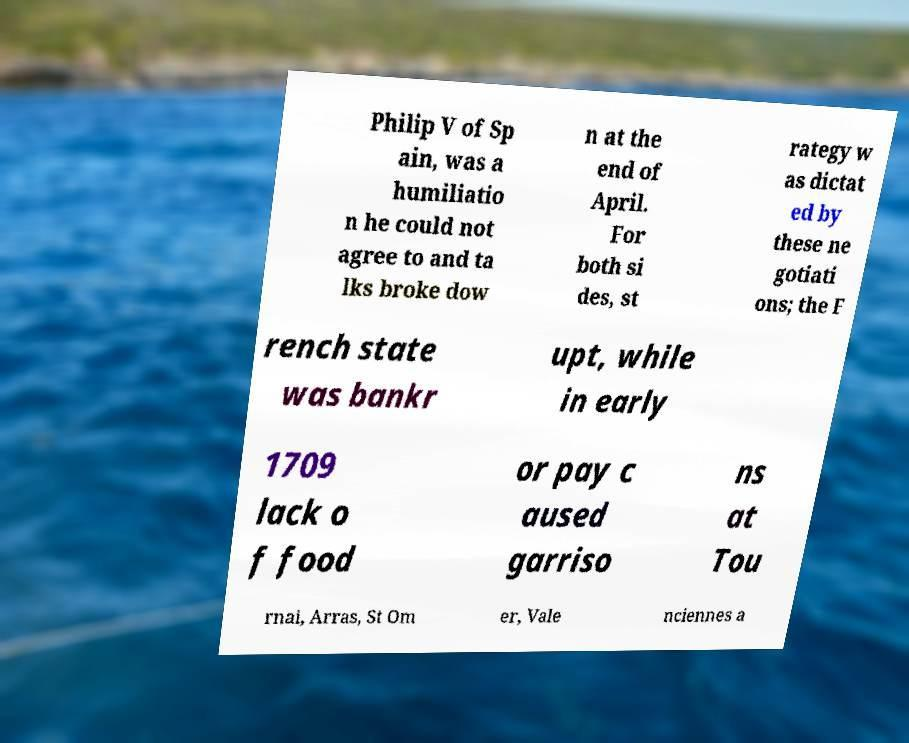There's text embedded in this image that I need extracted. Can you transcribe it verbatim? Philip V of Sp ain, was a humiliatio n he could not agree to and ta lks broke dow n at the end of April. For both si des, st rategy w as dictat ed by these ne gotiati ons; the F rench state was bankr upt, while in early 1709 lack o f food or pay c aused garriso ns at Tou rnai, Arras, St Om er, Vale nciennes a 